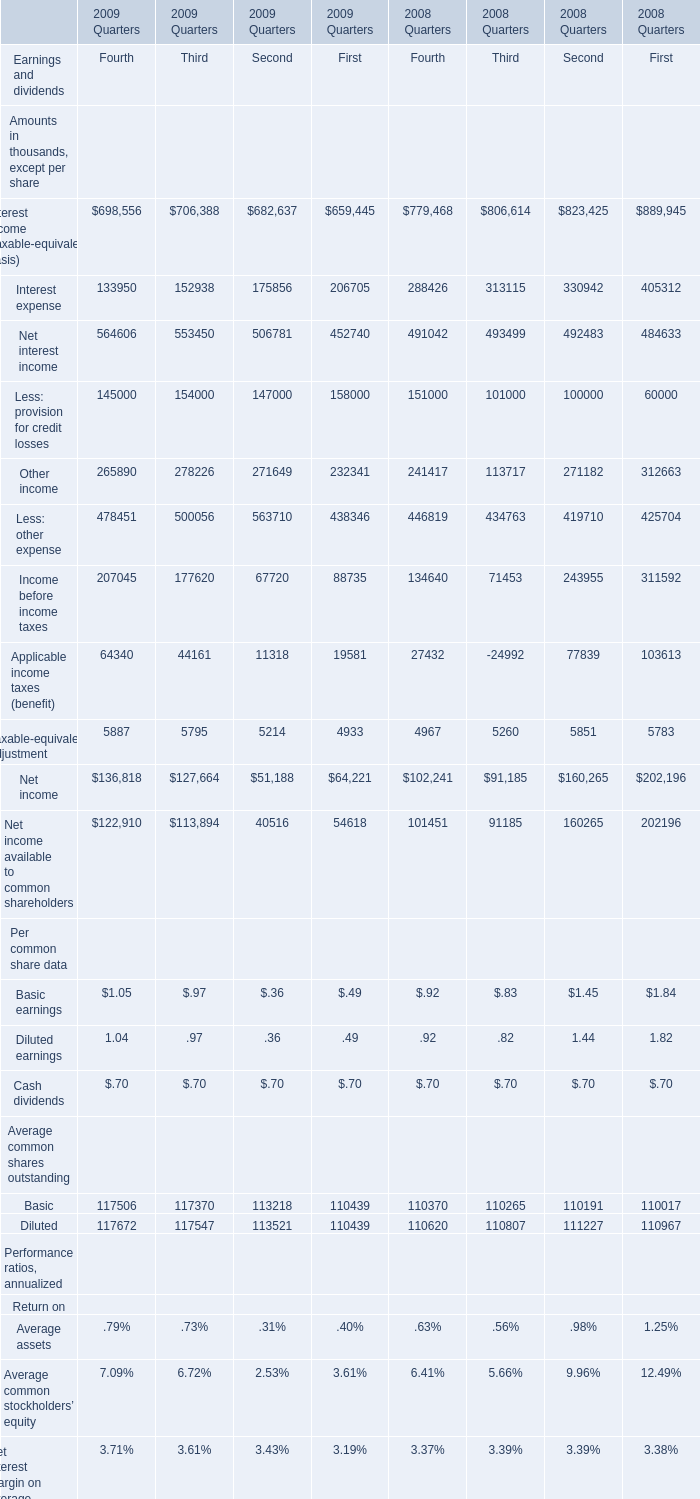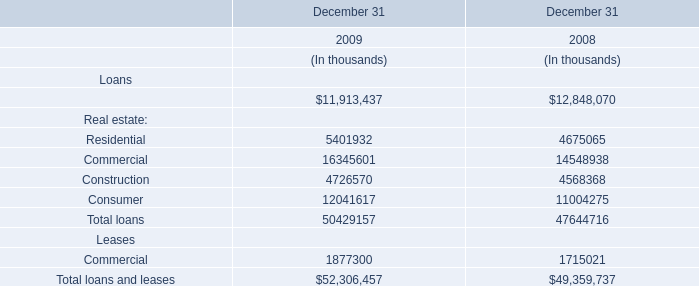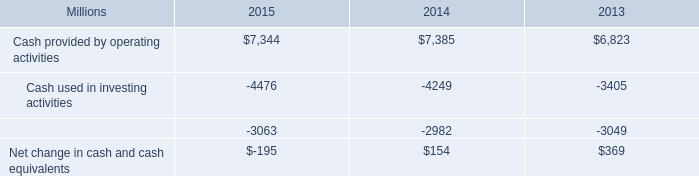What is the average value of Other income of Third in Table 0 and Commercial in Table 1 in 2009? 
Computations: (278226 / 16345601)
Answer: 0.01702. 